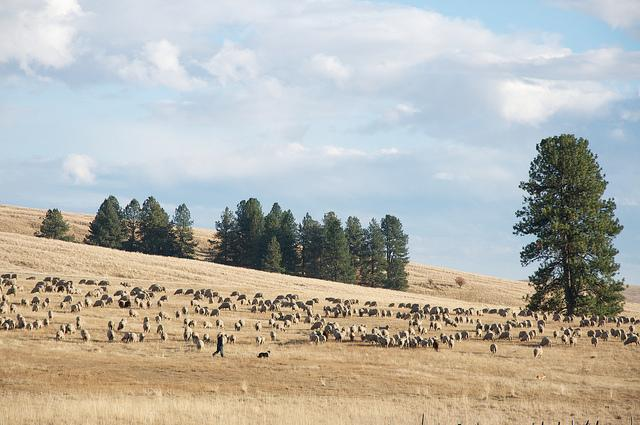What is the most probable reason there is a dog here?

Choices:
A) help blind
B) sniff bombs
C) watch house
D) heard animals heard animals 